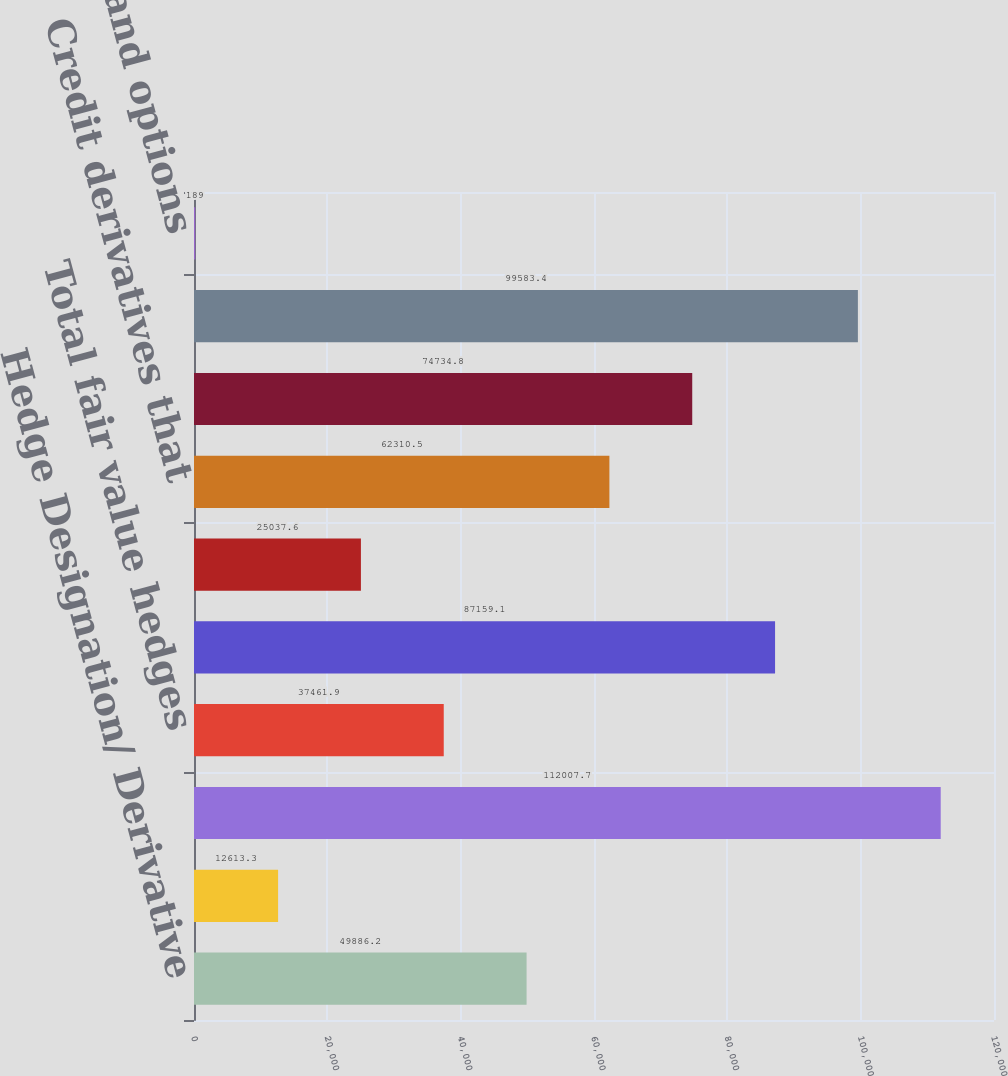<chart> <loc_0><loc_0><loc_500><loc_500><bar_chart><fcel>Hedge Designation/ Derivative<fcel>Foreign currency swaps<fcel>Total cash flow hedges<fcel>Total fair value hedges<fcel>Interest rate swaps caps<fcel>Foreign currency swaps and<fcel>Credit derivatives that<fcel>Credit derivatives that assume<fcel>Credit derivatives in<fcel>Equity index swaps and options<nl><fcel>49886.2<fcel>12613.3<fcel>112008<fcel>37461.9<fcel>87159.1<fcel>25037.6<fcel>62310.5<fcel>74734.8<fcel>99583.4<fcel>189<nl></chart> 